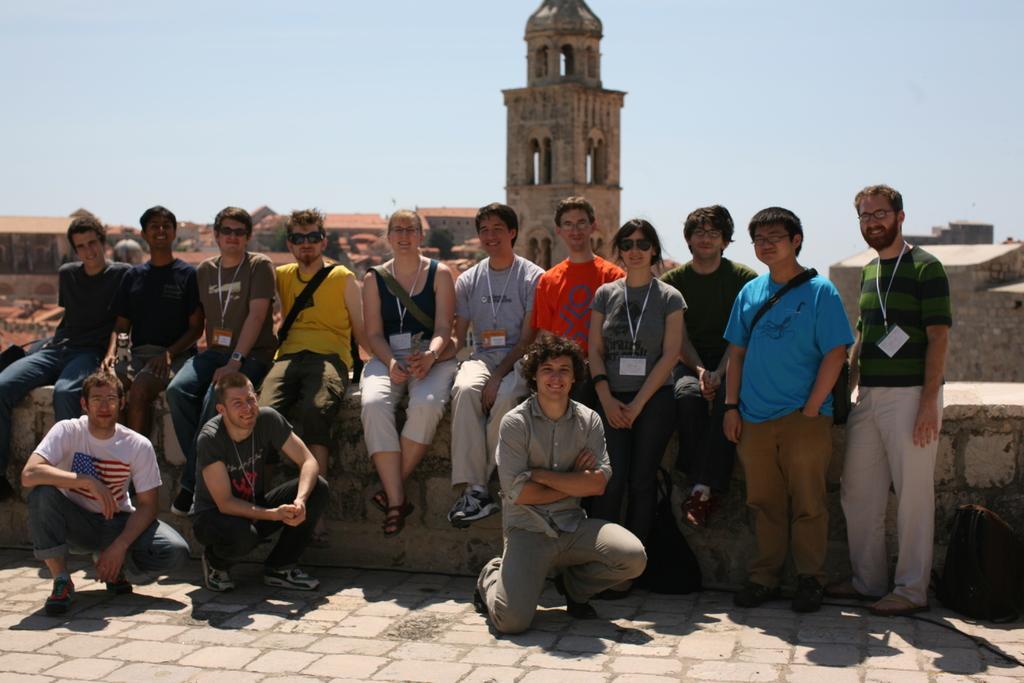How would you summarize this image in a sentence or two? In this image I can see a group of people are sitting on a fence and are standing on the road. In the background I can see a fort, trees and the sky. This image is taken may be during a day. 